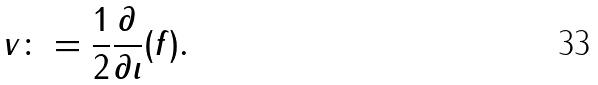Convert formula to latex. <formula><loc_0><loc_0><loc_500><loc_500>v \colon = \frac { 1 } { 2 } \frac { \partial } { \partial \iota } ( f ) .</formula> 